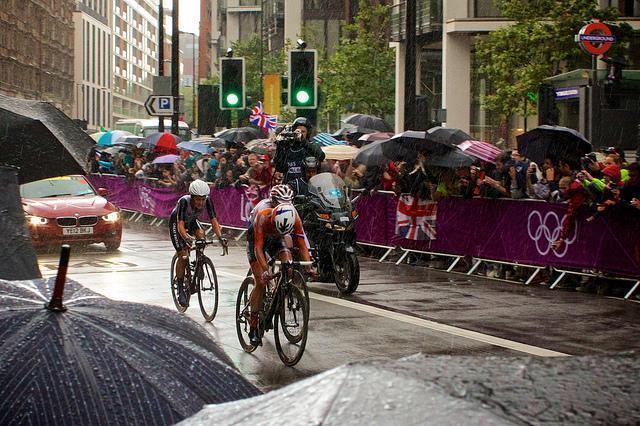When was the Union Jack invented?
Answer the question by selecting the correct answer among the 4 following choices and explain your choice with a short sentence. The answer should be formatted with the following format: `Answer: choice
Rationale: rationale.`
Options: 1606, 1612, 1672, 1619. Answer: 1606.
Rationale: The union jack was invented just after 1600. 